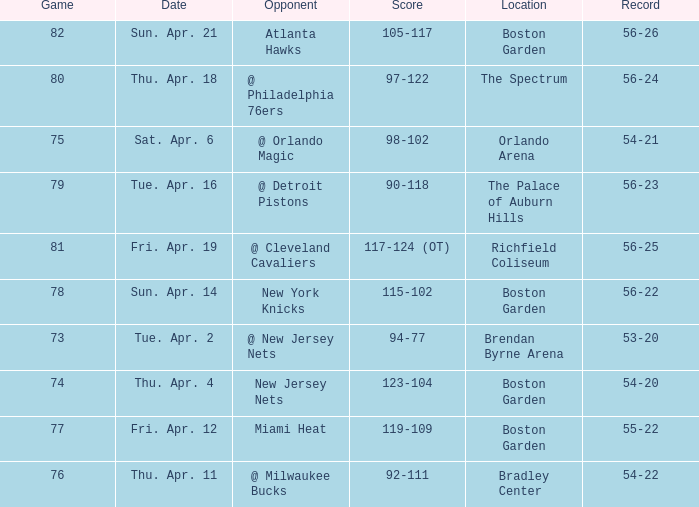Where was game 78 held? Boston Garden. 